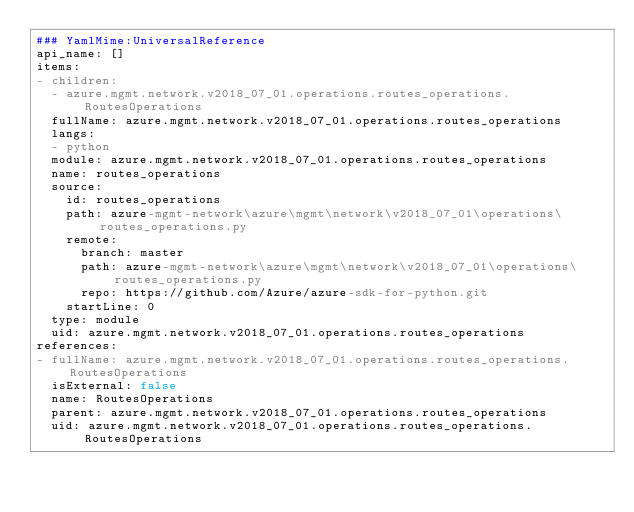Convert code to text. <code><loc_0><loc_0><loc_500><loc_500><_YAML_>### YamlMime:UniversalReference
api_name: []
items:
- children:
  - azure.mgmt.network.v2018_07_01.operations.routes_operations.RoutesOperations
  fullName: azure.mgmt.network.v2018_07_01.operations.routes_operations
  langs:
  - python
  module: azure.mgmt.network.v2018_07_01.operations.routes_operations
  name: routes_operations
  source:
    id: routes_operations
    path: azure-mgmt-network\azure\mgmt\network\v2018_07_01\operations\routes_operations.py
    remote:
      branch: master
      path: azure-mgmt-network\azure\mgmt\network\v2018_07_01\operations\routes_operations.py
      repo: https://github.com/Azure/azure-sdk-for-python.git
    startLine: 0
  type: module
  uid: azure.mgmt.network.v2018_07_01.operations.routes_operations
references:
- fullName: azure.mgmt.network.v2018_07_01.operations.routes_operations.RoutesOperations
  isExternal: false
  name: RoutesOperations
  parent: azure.mgmt.network.v2018_07_01.operations.routes_operations
  uid: azure.mgmt.network.v2018_07_01.operations.routes_operations.RoutesOperations
</code> 